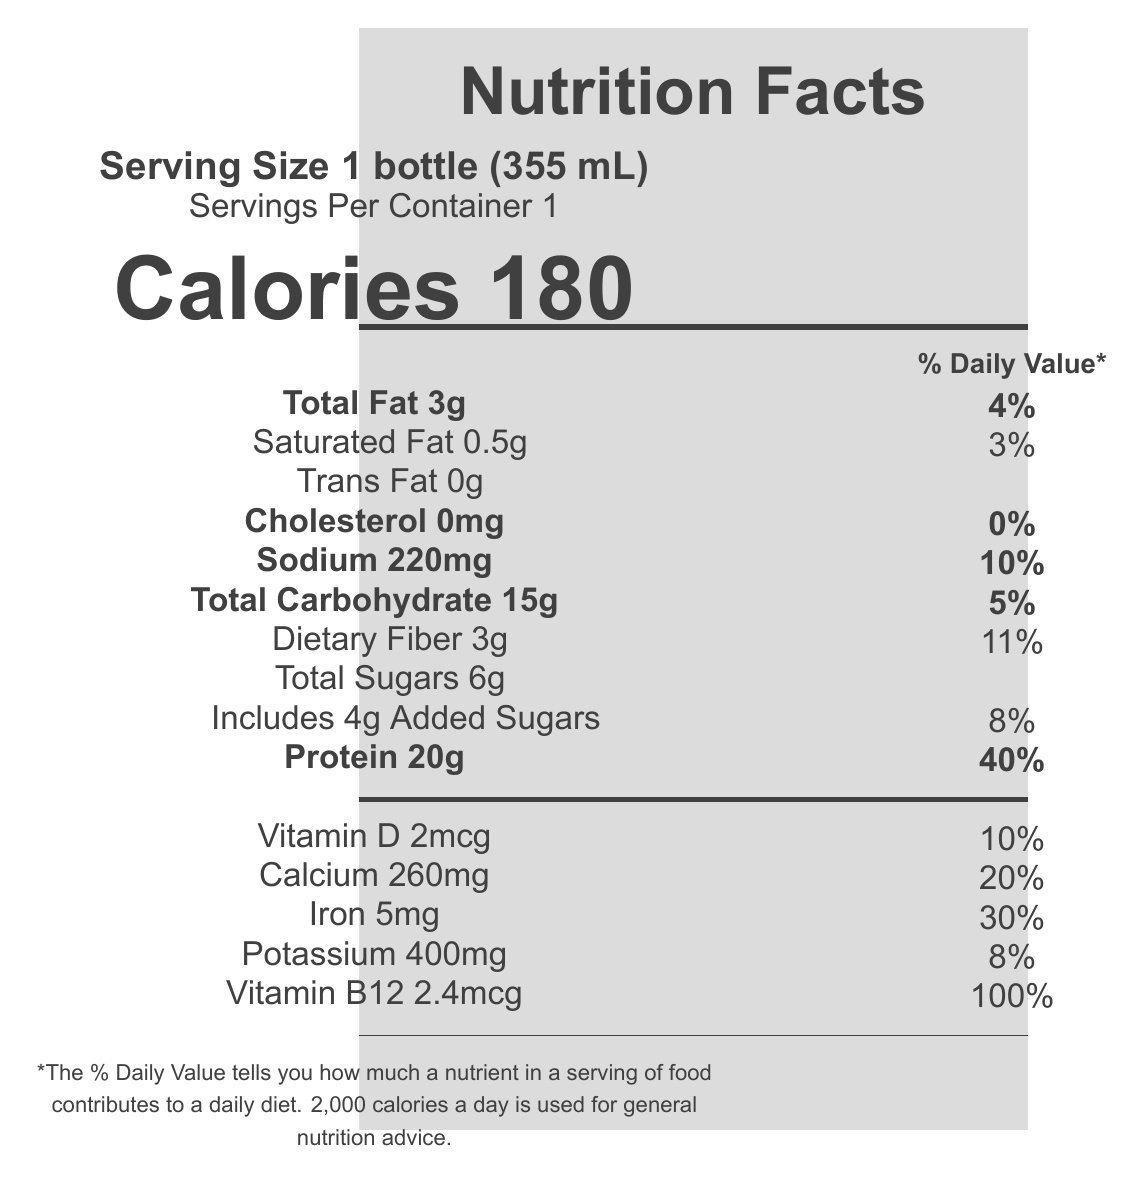what is the serving size? The serving size is specified as "1 bottle (355 mL)" in the serving size information.
Answer: 1 bottle (355 mL) how many calories are in one serving? The calories per serving are listed as 180 in the document.
Answer: 180 what percentage of the daily value for protein does this product provide? The protein amount is given as 20g, which corresponds to 40% of the daily value.
Answer: 40% how much total fat is in the shake? The document lists the total fat content as 3g.
Answer: 3g is this product vegan? The product is certified as "Certified Vegan," which is mentioned in the certifications section.
Answer: Yes how much Vitamin D is in one serving? The document specifies that one serving contains 2mcg of Vitamin D.
Answer: 2mcg does this product contain any cholesterol? The document states the cholesterol content as 0mg, meaning there is no cholesterol.
Answer: No how much sodium is in the protein shake? The sodium content per serving is listed as 220mg.
Answer: 220mg does the product have any added sugars? The document states that the product includes 4g of added sugars.
Answer: Yes how much dietary fiber does a bottle contain? The dietary fiber content is listed as 3g in the document.
Answer: 3g what certifications does this product have? Select all that apply: I. USDA Organic II. Non-GMO Project Verified III. Certified Gluten-Free IV. Fair Trade Certified ingredients The product is certified as USDA Organic, Non-GMO Project Verified, and Fair Trade Certified ingredients, but there is no mention of Certified Gluten-Free.
Answer: I, II, IV are there any artificial flavors, colors, or preservatives in this shake? The marketing claims section states that the product has no artificial flavors, colors, or preservatives.
Answer: No how much calcium is in one serving? The document lists the calcium content as 260mg per serving.
Answer: 260mg how many grams of saturated fat are in the shake? The saturated fat content is listed as 0.5g in the document.
Answer: 0.5g what is the main idea of the document? The entire document showcases the nutritional details, ingredient list, allergen information, and marketing claims of the protein shake, emphasizing its health benefits and alignments with ethical and sustainable practices.
Answer: The document provides the nutritional information and certifications for the "CinemaFuel Organic Plant Protein Shake," highlighting its suitability for documentary crew members with attributes such as high protein content, vegan and gluten-free certifications, and use of organic and fair-trade ingredients. what percentage of daily calcium does the shake provide? The calcium content is listed as 260mg, which corresponds to 20% of the daily value.
Answer: 20% how much iron is in one bottle? The document specifies that one serving contains 5mg of iron.
Answer: 5mg what is the serving size in grams? The document provides the serving size in milliliters (355 mL) but does not specify the serving size in grams.
Answer: Cannot be determined does the document list the exact carbohydrate sources? The document lists the total carbohydrate content and daily value percentage but does not break down the sources of carbohydrates specifically.
Answer: No 